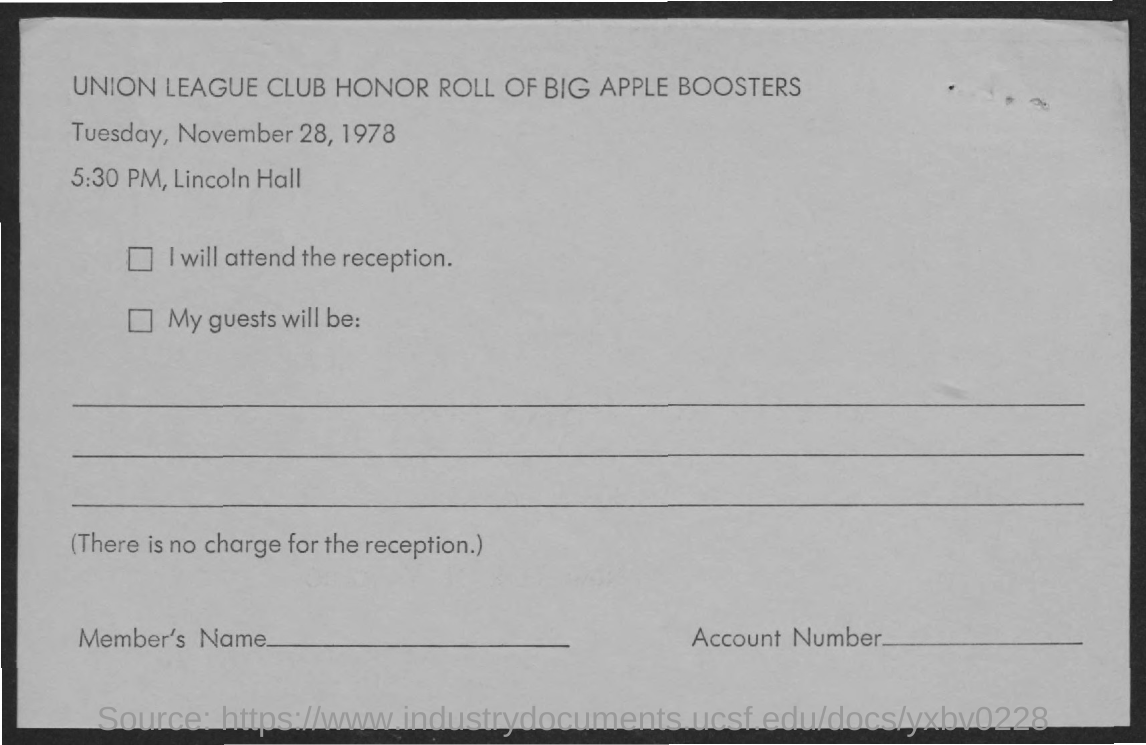When is the Union League Club Honor Roll of Big Apple Boosters?
Give a very brief answer. TUESDAY, NOVEMBER 28, 1978. Where is the Union League Club Honor Roll of Big Apple Boosters?
Give a very brief answer. Lincoln Hall. 